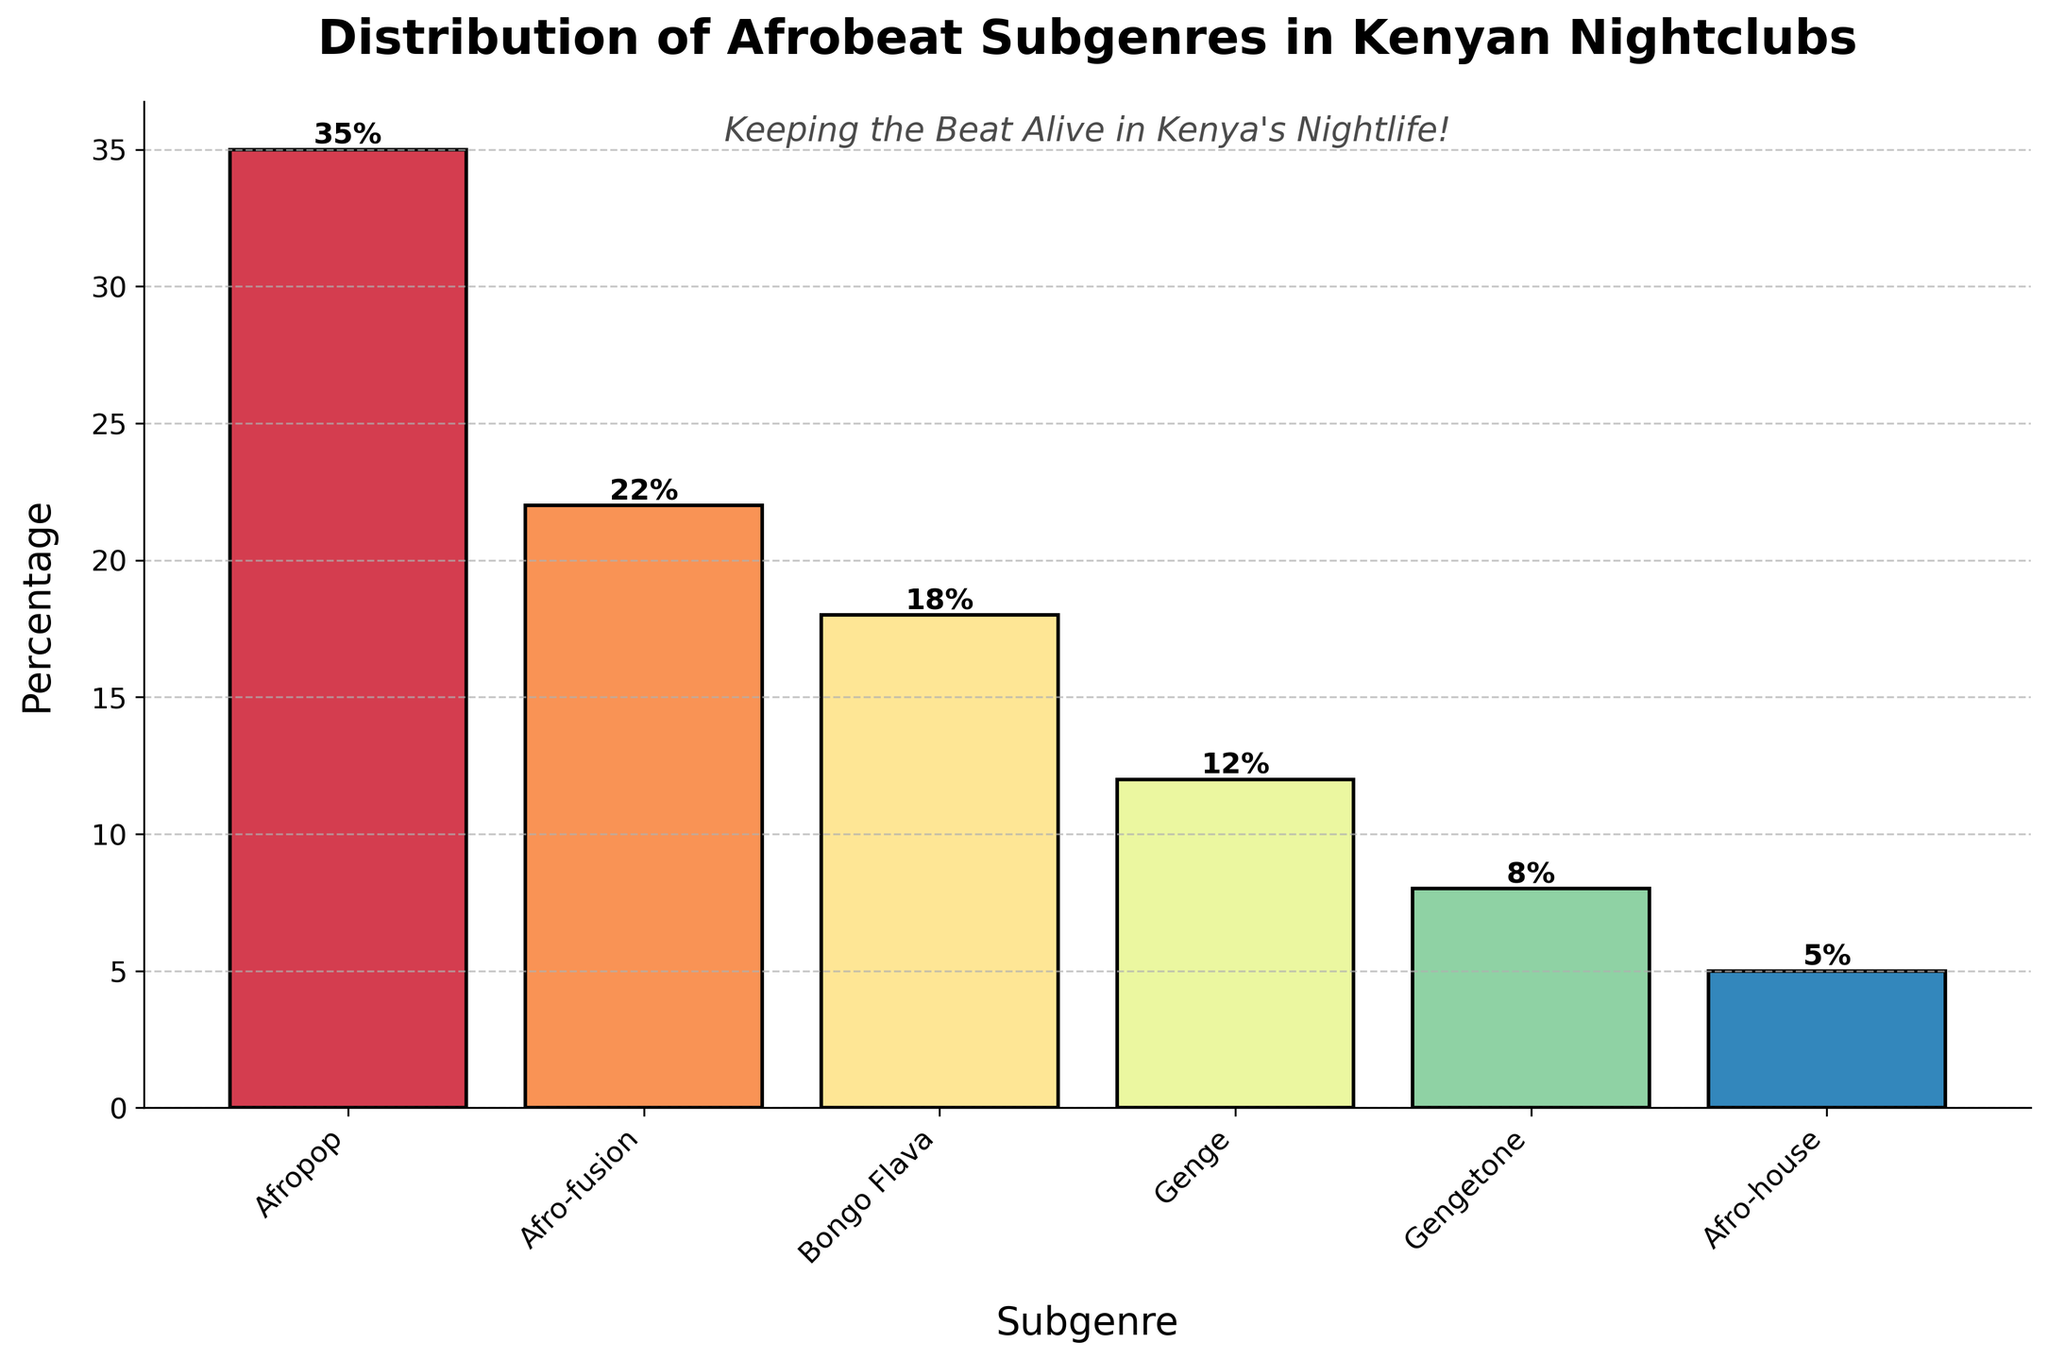Which Afrobeat subgenre has the highest percentage? The subgenre with the highest percentage can be identified by looking at which bar is tallest in the bar chart. Afropop has the tallest bar, making it the subgenre with the highest percentage
Answer: Afropop Which Afrobeat subgenre has the smallest representation in Kenyan nightclubs? The subgenre with the smallest representation can be identified by looking for the shortest bar in the bar chart. The shortest bar represents Afro-house
Answer: Afro-house What is the total percentage of Afrobeat subgenres Bongo Flava, Genge, and Gengetone combined? Add the percentages of Bongo Flava, Genge, and Gengetone: 18% (Bongo Flava) + 12% (Genge) + 8% (Gengetone) = 38%
Answer: 38% How much higher is the percentage of Afropop compared to Gengetone? Subtract the percentage of Gengetone from the percentage of Afropop: 35% (Afropop) - 8% (Gengetone) = 27%
Answer: 27% Which two subgenres together constitute more than 50% of the total distribution? Add the percentages of the highest subgenres sequentially till the sum exceeds 50%. Afropop (35%) + Afro-fusion (22%) = 57%, which is more than 50%
Answer: Afropop and Afro-fusion Which subgenre is represented by the second tallest bar? The second tallest bar corresponds to the subgenre with the second highest percentage. The second tallest bar represents Afro-fusion
Answer: Afro-fusion By how much does the percentage of Afro-fusion exceed that of Afro-house? Subtract the percentage of Afro-house from the percentage of Afro-fusion: 22% (Afro-fusion) - 5% (Afro-house) = 17%
Answer: 17% Which subgenre has a percentage closest to 20%? Identify the subgenre whose percentage is nearest to 20%. Afro-fusion is closest with 22%
Answer: Afro-fusion What percentage of the total distribution do Bongo Flava and Genge represent together? Add the percentages of Bongo Flava and Genge: 18% (Bongo Flava) + 12% (Genge) = 30%
Answer: 30% How many subgenres have a percentage greater than 10%? Count the subgenres whose percentages are more than 10%. The subgenres are Afropop (35%), Afro-fusion (22%), Bongo Flava (18%), and Genge (12%) – making it a total of 4 subgenres
Answer: 4 